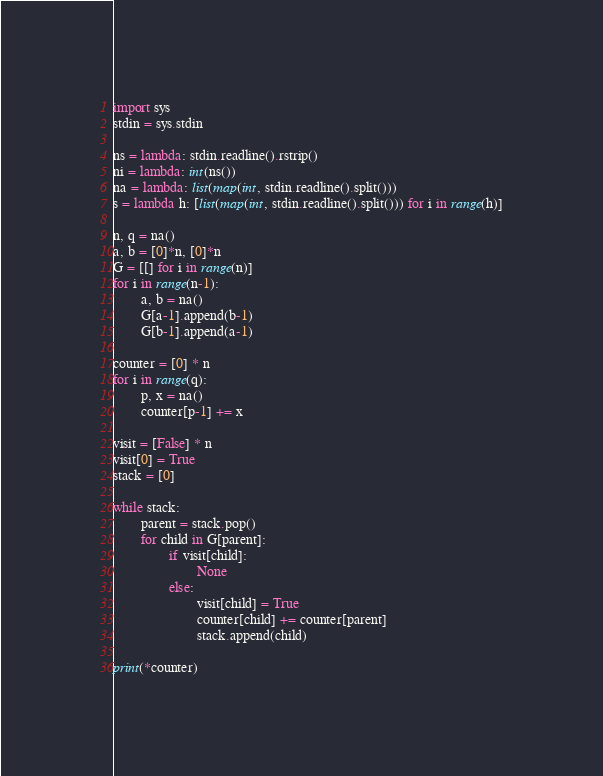Convert code to text. <code><loc_0><loc_0><loc_500><loc_500><_Python_>import sys
stdin = sys.stdin
 
ns = lambda: stdin.readline().rstrip()
ni = lambda: int(ns())
na = lambda: list(map(int, stdin.readline().split()))
s = lambda h: [list(map(int, stdin.readline().split())) for i in range(h)]

n, q = na()
a, b = [0]*n, [0]*n
G = [[] for i in range(n)]
for i in range(n-1):
        a, b = na()
        G[a-1].append(b-1)
        G[b-1].append(a-1)

counter = [0] * n
for i in range(q):
        p, x = na()
        counter[p-1] += x

visit = [False] * n
visit[0] = True
stack = [0]

while stack:
        parent = stack.pop()
        for child in G[parent]:
                if visit[child]:
                        None
                else:
                        visit[child] = True
                        counter[child] += counter[parent]
                        stack.append(child)

print(*counter)</code> 